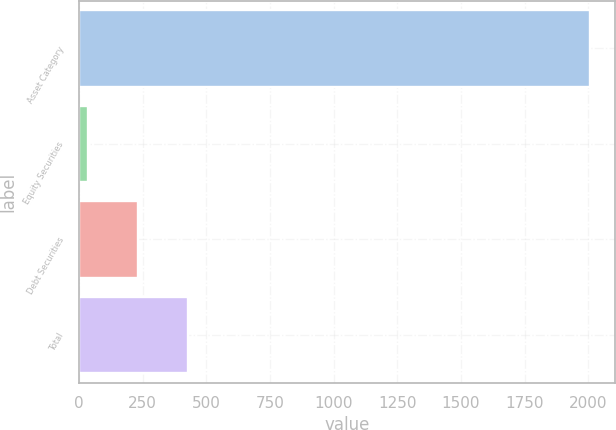Convert chart. <chart><loc_0><loc_0><loc_500><loc_500><bar_chart><fcel>Asset Category<fcel>Equity Securities<fcel>Debt Securities<fcel>Total<nl><fcel>2006<fcel>34<fcel>231.2<fcel>428.4<nl></chart> 